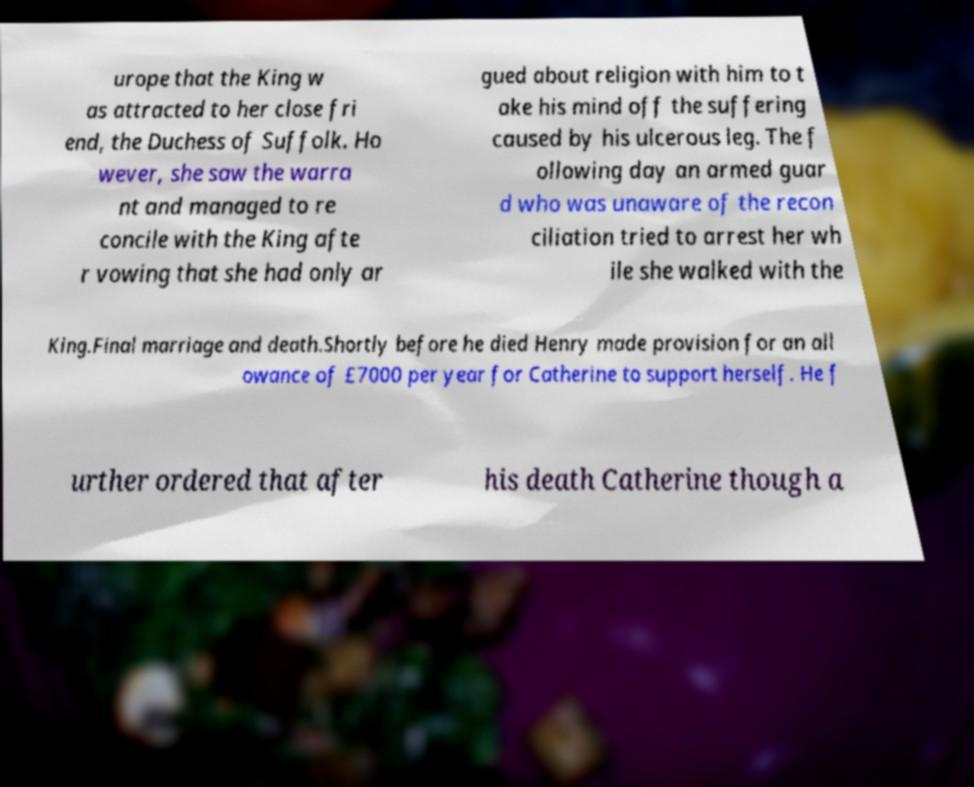What messages or text are displayed in this image? I need them in a readable, typed format. urope that the King w as attracted to her close fri end, the Duchess of Suffolk. Ho wever, she saw the warra nt and managed to re concile with the King afte r vowing that she had only ar gued about religion with him to t ake his mind off the suffering caused by his ulcerous leg. The f ollowing day an armed guar d who was unaware of the recon ciliation tried to arrest her wh ile she walked with the King.Final marriage and death.Shortly before he died Henry made provision for an all owance of £7000 per year for Catherine to support herself. He f urther ordered that after his death Catherine though a 